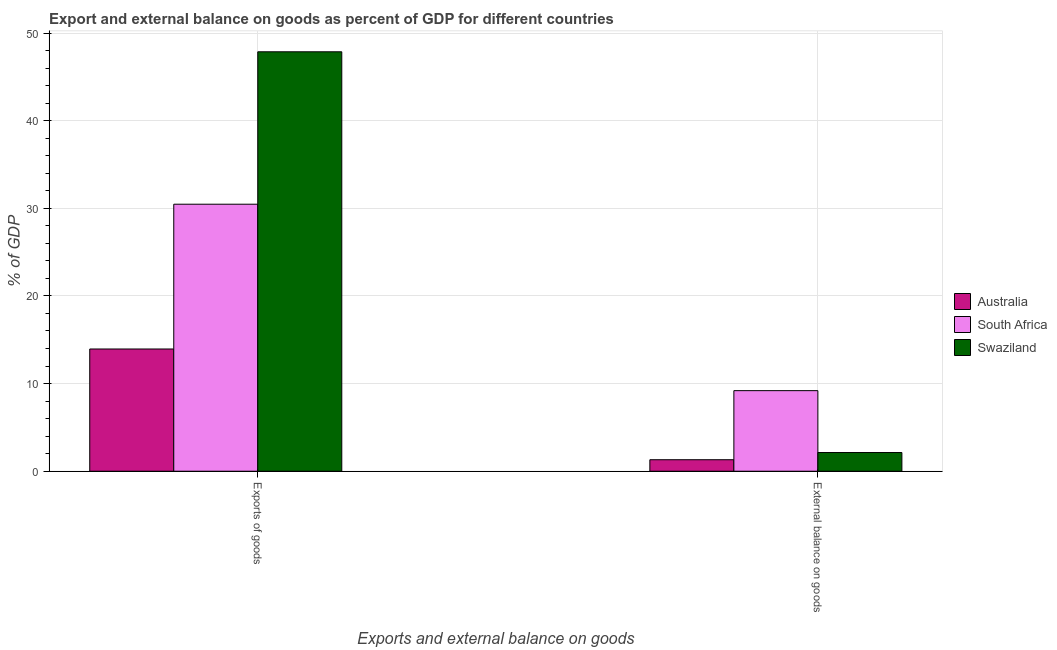How many bars are there on the 2nd tick from the left?
Your response must be concise. 3. How many bars are there on the 1st tick from the right?
Your answer should be compact. 3. What is the label of the 2nd group of bars from the left?
Ensure brevity in your answer.  External balance on goods. What is the external balance on goods as percentage of gdp in Swaziland?
Ensure brevity in your answer.  2.13. Across all countries, what is the maximum external balance on goods as percentage of gdp?
Your answer should be compact. 9.19. Across all countries, what is the minimum export of goods as percentage of gdp?
Your response must be concise. 13.95. In which country was the export of goods as percentage of gdp maximum?
Give a very brief answer. Swaziland. What is the total external balance on goods as percentage of gdp in the graph?
Your answer should be compact. 12.64. What is the difference between the export of goods as percentage of gdp in Australia and that in South Africa?
Your answer should be very brief. -16.52. What is the difference between the export of goods as percentage of gdp in South Africa and the external balance on goods as percentage of gdp in Australia?
Offer a very short reply. 29.15. What is the average export of goods as percentage of gdp per country?
Your answer should be compact. 30.76. What is the difference between the export of goods as percentage of gdp and external balance on goods as percentage of gdp in Swaziland?
Ensure brevity in your answer.  45.72. What is the ratio of the external balance on goods as percentage of gdp in South Africa to that in Swaziland?
Your answer should be very brief. 4.31. Is the export of goods as percentage of gdp in Swaziland less than that in South Africa?
Ensure brevity in your answer.  No. What does the 1st bar from the right in Exports of goods represents?
Provide a short and direct response. Swaziland. What is the difference between two consecutive major ticks on the Y-axis?
Your answer should be compact. 10. Does the graph contain any zero values?
Ensure brevity in your answer.  No. Where does the legend appear in the graph?
Provide a succinct answer. Center right. How many legend labels are there?
Make the answer very short. 3. How are the legend labels stacked?
Keep it short and to the point. Vertical. What is the title of the graph?
Your response must be concise. Export and external balance on goods as percent of GDP for different countries. What is the label or title of the X-axis?
Give a very brief answer. Exports and external balance on goods. What is the label or title of the Y-axis?
Keep it short and to the point. % of GDP. What is the % of GDP in Australia in Exports of goods?
Your answer should be compact. 13.95. What is the % of GDP in South Africa in Exports of goods?
Your response must be concise. 30.47. What is the % of GDP of Swaziland in Exports of goods?
Offer a terse response. 47.86. What is the % of GDP in Australia in External balance on goods?
Your response must be concise. 1.31. What is the % of GDP of South Africa in External balance on goods?
Provide a succinct answer. 9.19. What is the % of GDP in Swaziland in External balance on goods?
Offer a very short reply. 2.13. Across all Exports and external balance on goods, what is the maximum % of GDP of Australia?
Provide a succinct answer. 13.95. Across all Exports and external balance on goods, what is the maximum % of GDP of South Africa?
Provide a succinct answer. 30.47. Across all Exports and external balance on goods, what is the maximum % of GDP of Swaziland?
Provide a short and direct response. 47.86. Across all Exports and external balance on goods, what is the minimum % of GDP in Australia?
Your answer should be compact. 1.31. Across all Exports and external balance on goods, what is the minimum % of GDP in South Africa?
Your answer should be very brief. 9.19. Across all Exports and external balance on goods, what is the minimum % of GDP in Swaziland?
Keep it short and to the point. 2.13. What is the total % of GDP in Australia in the graph?
Give a very brief answer. 15.26. What is the total % of GDP in South Africa in the graph?
Your answer should be compact. 39.66. What is the total % of GDP in Swaziland in the graph?
Offer a very short reply. 49.99. What is the difference between the % of GDP of Australia in Exports of goods and that in External balance on goods?
Give a very brief answer. 12.63. What is the difference between the % of GDP in South Africa in Exports of goods and that in External balance on goods?
Offer a very short reply. 21.27. What is the difference between the % of GDP in Swaziland in Exports of goods and that in External balance on goods?
Your answer should be very brief. 45.72. What is the difference between the % of GDP of Australia in Exports of goods and the % of GDP of South Africa in External balance on goods?
Offer a very short reply. 4.75. What is the difference between the % of GDP in Australia in Exports of goods and the % of GDP in Swaziland in External balance on goods?
Offer a very short reply. 11.81. What is the difference between the % of GDP in South Africa in Exports of goods and the % of GDP in Swaziland in External balance on goods?
Offer a terse response. 28.33. What is the average % of GDP in Australia per Exports and external balance on goods?
Your response must be concise. 7.63. What is the average % of GDP in South Africa per Exports and external balance on goods?
Your answer should be very brief. 19.83. What is the average % of GDP in Swaziland per Exports and external balance on goods?
Offer a terse response. 25. What is the difference between the % of GDP in Australia and % of GDP in South Africa in Exports of goods?
Keep it short and to the point. -16.52. What is the difference between the % of GDP in Australia and % of GDP in Swaziland in Exports of goods?
Provide a short and direct response. -33.91. What is the difference between the % of GDP in South Africa and % of GDP in Swaziland in Exports of goods?
Keep it short and to the point. -17.39. What is the difference between the % of GDP of Australia and % of GDP of South Africa in External balance on goods?
Offer a terse response. -7.88. What is the difference between the % of GDP in Australia and % of GDP in Swaziland in External balance on goods?
Ensure brevity in your answer.  -0.82. What is the difference between the % of GDP of South Africa and % of GDP of Swaziland in External balance on goods?
Your response must be concise. 7.06. What is the ratio of the % of GDP of Australia in Exports of goods to that in External balance on goods?
Your response must be concise. 10.63. What is the ratio of the % of GDP of South Africa in Exports of goods to that in External balance on goods?
Ensure brevity in your answer.  3.31. What is the ratio of the % of GDP in Swaziland in Exports of goods to that in External balance on goods?
Offer a terse response. 22.43. What is the difference between the highest and the second highest % of GDP in Australia?
Ensure brevity in your answer.  12.63. What is the difference between the highest and the second highest % of GDP in South Africa?
Provide a short and direct response. 21.27. What is the difference between the highest and the second highest % of GDP of Swaziland?
Make the answer very short. 45.72. What is the difference between the highest and the lowest % of GDP of Australia?
Keep it short and to the point. 12.63. What is the difference between the highest and the lowest % of GDP of South Africa?
Offer a very short reply. 21.27. What is the difference between the highest and the lowest % of GDP in Swaziland?
Offer a very short reply. 45.72. 